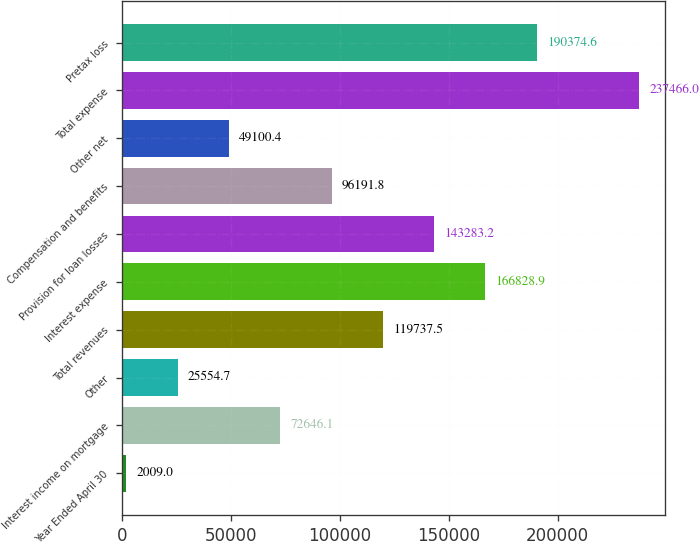<chart> <loc_0><loc_0><loc_500><loc_500><bar_chart><fcel>Year Ended April 30<fcel>Interest income on mortgage<fcel>Other<fcel>Total revenues<fcel>Interest expense<fcel>Provision for loan losses<fcel>Compensation and benefits<fcel>Other net<fcel>Total expense<fcel>Pretax loss<nl><fcel>2009<fcel>72646.1<fcel>25554.7<fcel>119738<fcel>166829<fcel>143283<fcel>96191.8<fcel>49100.4<fcel>237466<fcel>190375<nl></chart> 